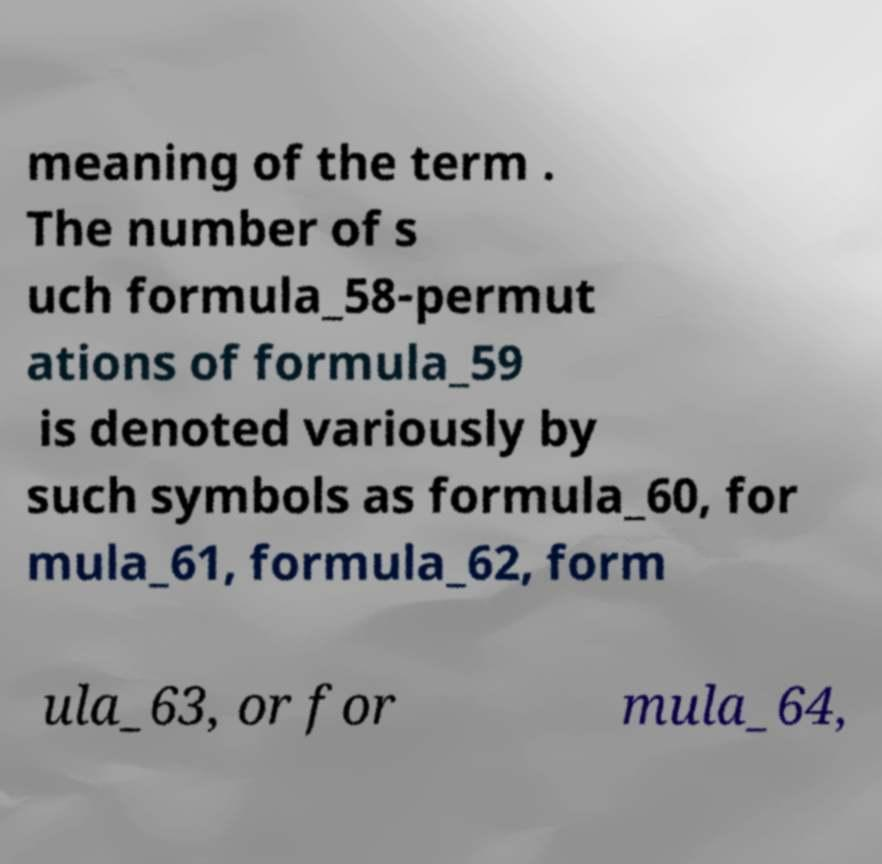I need the written content from this picture converted into text. Can you do that? meaning of the term . The number of s uch formula_58-permut ations of formula_59 is denoted variously by such symbols as formula_60, for mula_61, formula_62, form ula_63, or for mula_64, 